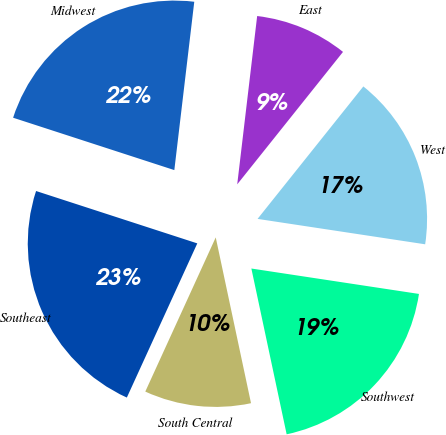Convert chart to OTSL. <chart><loc_0><loc_0><loc_500><loc_500><pie_chart><fcel>East<fcel>Midwest<fcel>Southeast<fcel>South Central<fcel>Southwest<fcel>West<nl><fcel>8.85%<fcel>21.88%<fcel>23.18%<fcel>10.16%<fcel>19.27%<fcel>16.67%<nl></chart> 